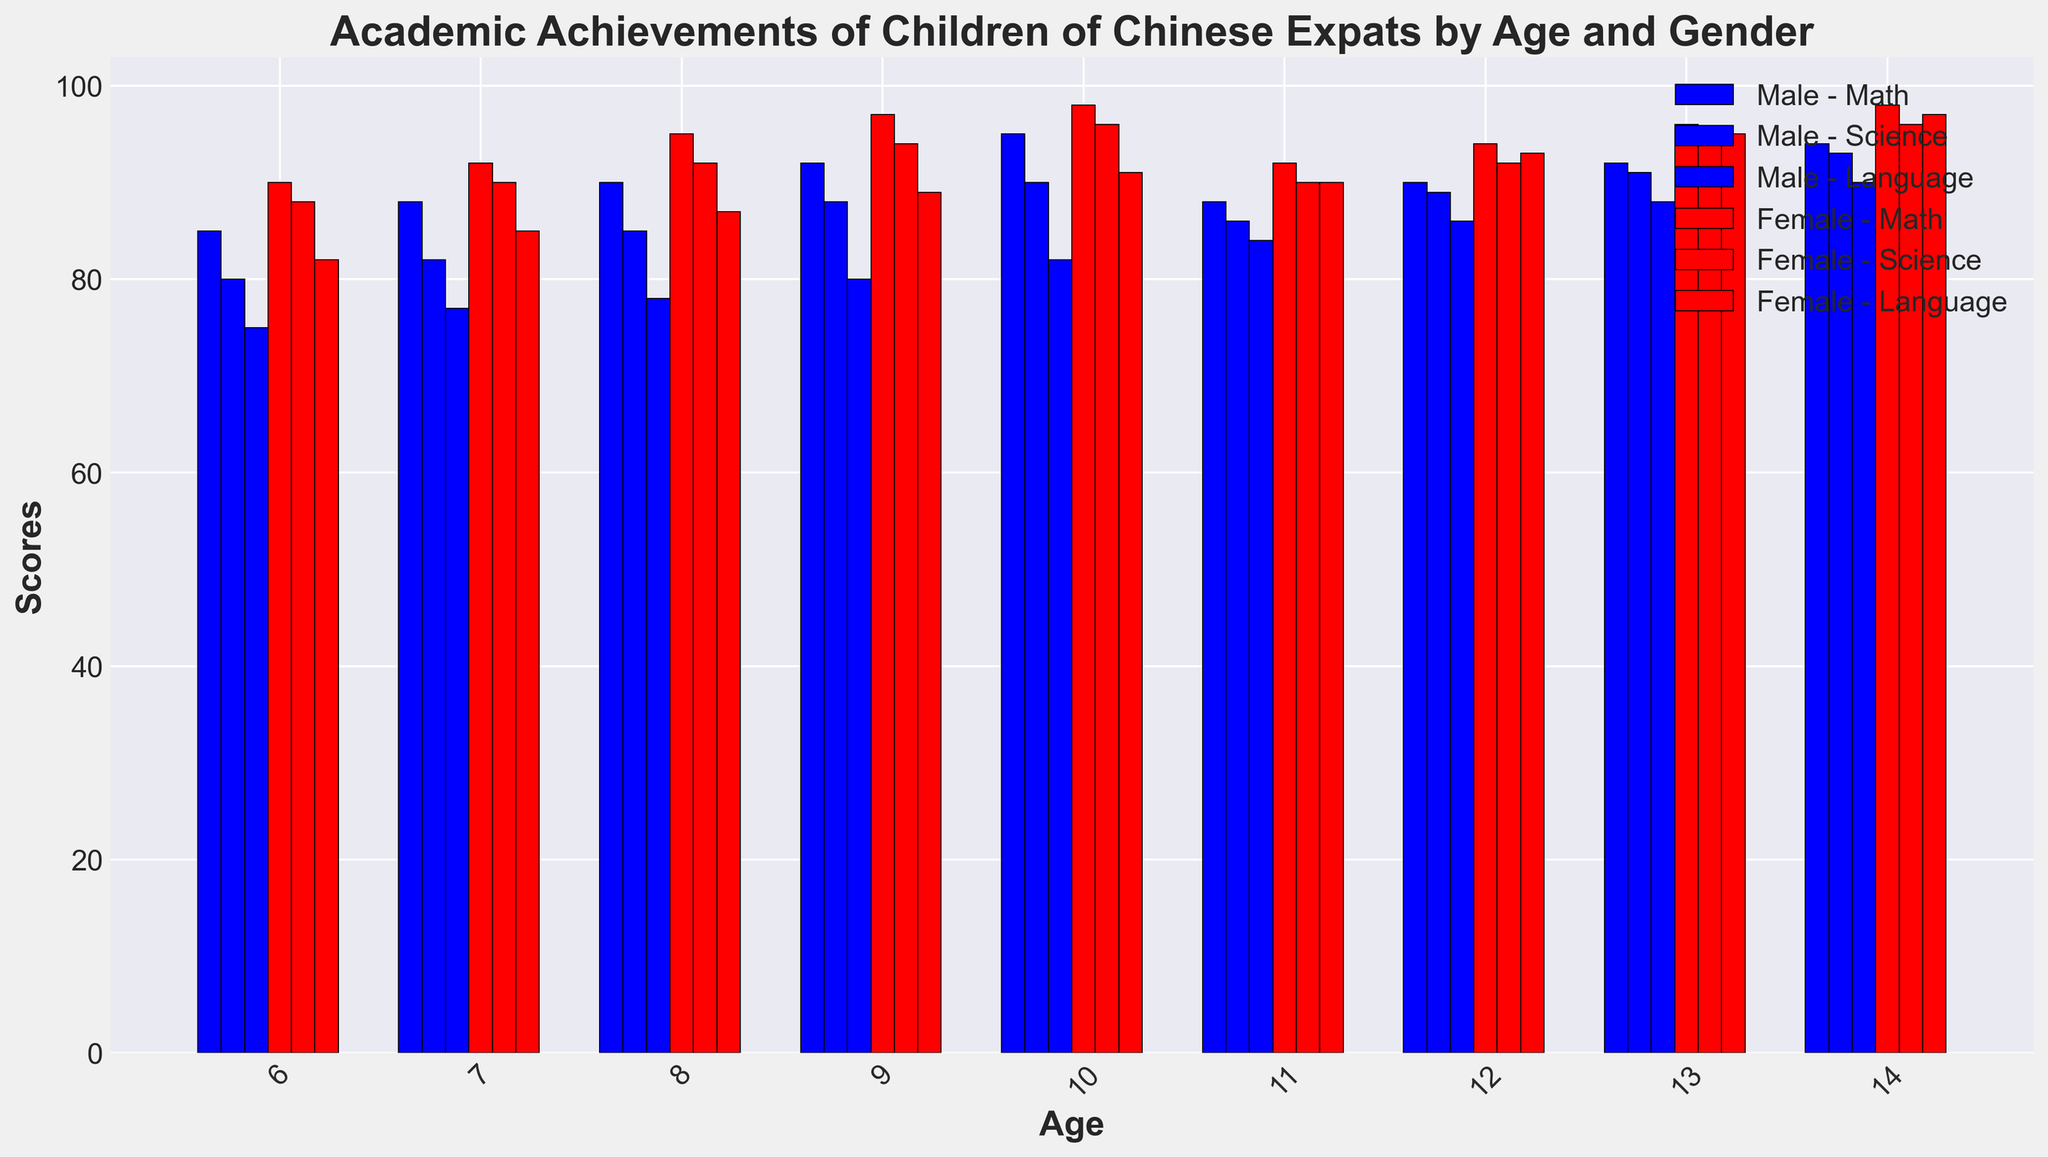What is the average Math score for 10-year-old children and which gender has a higher average? For 10-year-olds, the Math score for males is 95 and for females is 98. The average Math score = (95 + 98) / 2 = 96.5. Females have a higher Math score (98).
Answer: 96.5, Female Between 13-year-old males and females, who scored higher in Language, and by how much? 13-year-old males scored 88 in Language and females scored 95. The difference is 95 - 88 = 7. Females scored higher by 7 points.
Answer: Female, 7 points What is the total Science score for 6-year-old children? The scores for 6-year-olds in Science are 80 (male) and 88 (female). The total = 80 + 88 = 168.
Answer: 168 Compare the Math scores of 14-year-old males and females. Who did better and what's the difference? For 14-year-olds, males scored 94 in Math and females scored 98. The difference = 98 - 94 = 4. Females did better by 4 points.
Answer: Female, 4 points What is the average Language score for 11-year-old children? The Language scores for 11-year-olds are 84 (male) and 90 (female). The average = (84 + 90) / 2 = 87.
Answer: 87 Which age group has the highest average Science score among all children? Calculate the average Science score for each age group. The highest average is at age 14 with scores of 93 (male) and 96 (female). The average = (93 + 96) / 2 = 94.5.
Answer: 14 For 8-year-olds, how do female scores across all subjects compare to male scores? The scores for 8-year-olds are: Math (male 90, female 95), Science (male 85, female 92), Language (male 78, female 87). Females scored higher in every subject: Math by 5, Science by 7, Language by 9.
Answer: Female scores higher in all subjects In the Language subject, which age and gender group has the lowest score? Identify the lowest Language scores across all age and gender groups. The lowest score is for 6-year-old males, who scored 75.
Answer: 6-year-old males What is the difference in average Science scores between 7-year-olds and 12-year-olds? Calculate the average Science score for 7-year-olds (males 82 and females 90, average = (82 + 90) / 2 = 86) and 12-year-olds (males 89 and females 92, average = (89 + 92) / 2 = 90.5). Difference = 90.5 - 86 = 4.5.
Answer: 4.5 Which gender consistently scores higher in Math as they age and by how much on average? Compare Math scores for males and females across all ages: Females tend to score higher than males in each age group. The differences are: (6-5-5-5-3-2-4). Average difference = (5+4+5+5+3+2+4)/7 = 4.
Answer: Female, 4 points 